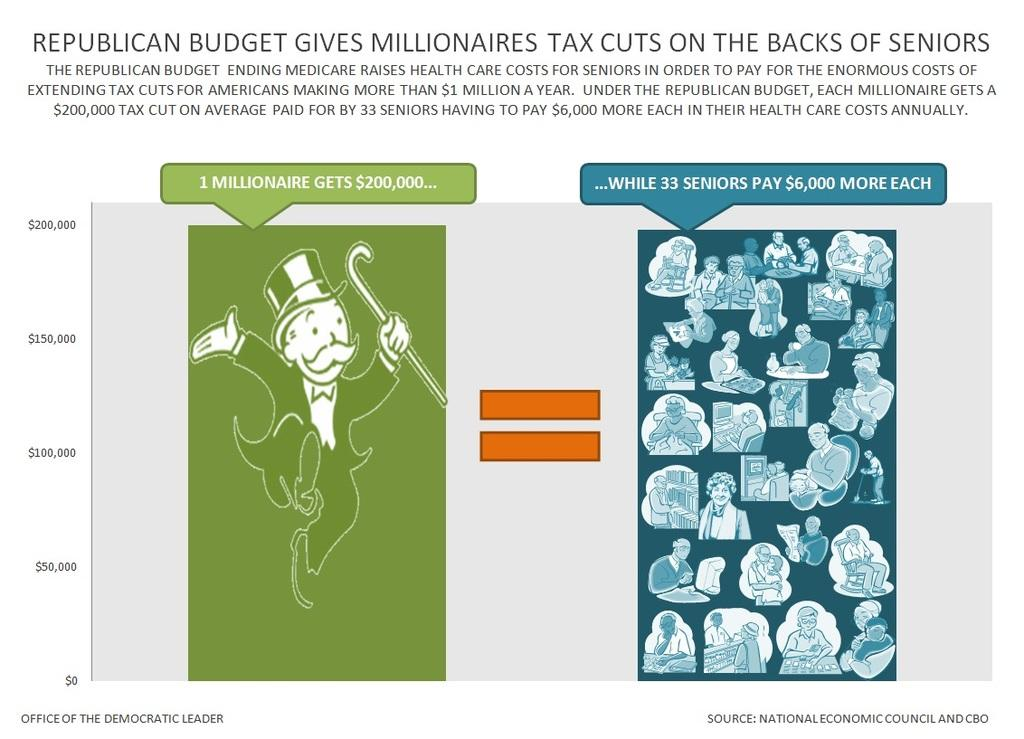Who or what is present in the image? There are people in the image. What else can be seen in the image besides the people? There are symbols and text on a page in the image. What type of silk material is being used to create the house in the image? There is no house or silk material present in the image. How many corks are visible in the image? There are no corks visible in the image. 